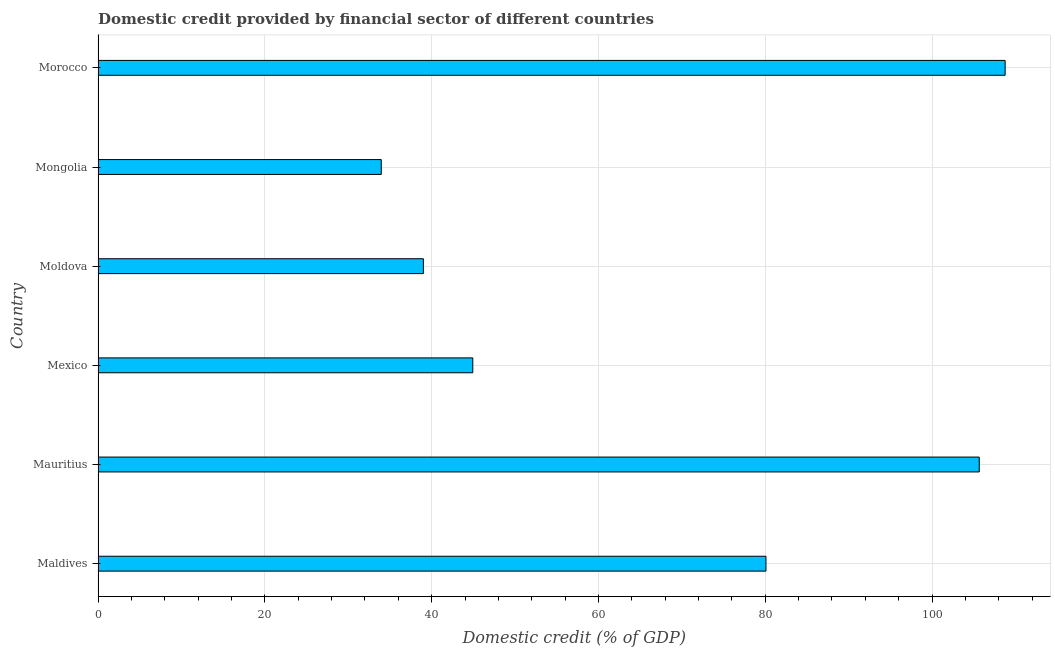Does the graph contain grids?
Provide a succinct answer. Yes. What is the title of the graph?
Make the answer very short. Domestic credit provided by financial sector of different countries. What is the label or title of the X-axis?
Offer a very short reply. Domestic credit (% of GDP). What is the label or title of the Y-axis?
Offer a terse response. Country. What is the domestic credit provided by financial sector in Mexico?
Give a very brief answer. 44.93. Across all countries, what is the maximum domestic credit provided by financial sector?
Offer a very short reply. 108.77. Across all countries, what is the minimum domestic credit provided by financial sector?
Give a very brief answer. 33.96. In which country was the domestic credit provided by financial sector maximum?
Provide a succinct answer. Morocco. In which country was the domestic credit provided by financial sector minimum?
Provide a succinct answer. Mongolia. What is the sum of the domestic credit provided by financial sector?
Provide a short and direct response. 412.42. What is the difference between the domestic credit provided by financial sector in Maldives and Moldova?
Provide a succinct answer. 41.08. What is the average domestic credit provided by financial sector per country?
Your answer should be very brief. 68.74. What is the median domestic credit provided by financial sector?
Provide a short and direct response. 62.51. What is the ratio of the domestic credit provided by financial sector in Mexico to that in Moldova?
Your answer should be compact. 1.15. Is the domestic credit provided by financial sector in Mexico less than that in Moldova?
Ensure brevity in your answer.  No. Is the difference between the domestic credit provided by financial sector in Mexico and Moldova greater than the difference between any two countries?
Your response must be concise. No. What is the difference between the highest and the second highest domestic credit provided by financial sector?
Keep it short and to the point. 3.1. What is the difference between the highest and the lowest domestic credit provided by financial sector?
Your answer should be very brief. 74.81. In how many countries, is the domestic credit provided by financial sector greater than the average domestic credit provided by financial sector taken over all countries?
Ensure brevity in your answer.  3. Are all the bars in the graph horizontal?
Your answer should be compact. Yes. How many countries are there in the graph?
Ensure brevity in your answer.  6. What is the Domestic credit (% of GDP) of Maldives?
Your answer should be compact. 80.09. What is the Domestic credit (% of GDP) in Mauritius?
Make the answer very short. 105.66. What is the Domestic credit (% of GDP) of Mexico?
Offer a very short reply. 44.93. What is the Domestic credit (% of GDP) of Moldova?
Your answer should be very brief. 39.01. What is the Domestic credit (% of GDP) of Mongolia?
Make the answer very short. 33.96. What is the Domestic credit (% of GDP) of Morocco?
Ensure brevity in your answer.  108.77. What is the difference between the Domestic credit (% of GDP) in Maldives and Mauritius?
Make the answer very short. -25.57. What is the difference between the Domestic credit (% of GDP) in Maldives and Mexico?
Provide a short and direct response. 35.15. What is the difference between the Domestic credit (% of GDP) in Maldives and Moldova?
Make the answer very short. 41.08. What is the difference between the Domestic credit (% of GDP) in Maldives and Mongolia?
Provide a short and direct response. 46.13. What is the difference between the Domestic credit (% of GDP) in Maldives and Morocco?
Your response must be concise. -28.68. What is the difference between the Domestic credit (% of GDP) in Mauritius and Mexico?
Your response must be concise. 60.73. What is the difference between the Domestic credit (% of GDP) in Mauritius and Moldova?
Offer a very short reply. 66.65. What is the difference between the Domestic credit (% of GDP) in Mauritius and Mongolia?
Make the answer very short. 71.7. What is the difference between the Domestic credit (% of GDP) in Mauritius and Morocco?
Offer a terse response. -3.1. What is the difference between the Domestic credit (% of GDP) in Mexico and Moldova?
Ensure brevity in your answer.  5.92. What is the difference between the Domestic credit (% of GDP) in Mexico and Mongolia?
Keep it short and to the point. 10.98. What is the difference between the Domestic credit (% of GDP) in Mexico and Morocco?
Provide a short and direct response. -63.83. What is the difference between the Domestic credit (% of GDP) in Moldova and Mongolia?
Provide a succinct answer. 5.05. What is the difference between the Domestic credit (% of GDP) in Moldova and Morocco?
Offer a terse response. -69.76. What is the difference between the Domestic credit (% of GDP) in Mongolia and Morocco?
Make the answer very short. -74.81. What is the ratio of the Domestic credit (% of GDP) in Maldives to that in Mauritius?
Your response must be concise. 0.76. What is the ratio of the Domestic credit (% of GDP) in Maldives to that in Mexico?
Your response must be concise. 1.78. What is the ratio of the Domestic credit (% of GDP) in Maldives to that in Moldova?
Offer a terse response. 2.05. What is the ratio of the Domestic credit (% of GDP) in Maldives to that in Mongolia?
Keep it short and to the point. 2.36. What is the ratio of the Domestic credit (% of GDP) in Maldives to that in Morocco?
Ensure brevity in your answer.  0.74. What is the ratio of the Domestic credit (% of GDP) in Mauritius to that in Mexico?
Keep it short and to the point. 2.35. What is the ratio of the Domestic credit (% of GDP) in Mauritius to that in Moldova?
Your response must be concise. 2.71. What is the ratio of the Domestic credit (% of GDP) in Mauritius to that in Mongolia?
Your response must be concise. 3.11. What is the ratio of the Domestic credit (% of GDP) in Mexico to that in Moldova?
Your answer should be compact. 1.15. What is the ratio of the Domestic credit (% of GDP) in Mexico to that in Mongolia?
Ensure brevity in your answer.  1.32. What is the ratio of the Domestic credit (% of GDP) in Mexico to that in Morocco?
Make the answer very short. 0.41. What is the ratio of the Domestic credit (% of GDP) in Moldova to that in Mongolia?
Your answer should be compact. 1.15. What is the ratio of the Domestic credit (% of GDP) in Moldova to that in Morocco?
Make the answer very short. 0.36. What is the ratio of the Domestic credit (% of GDP) in Mongolia to that in Morocco?
Provide a succinct answer. 0.31. 